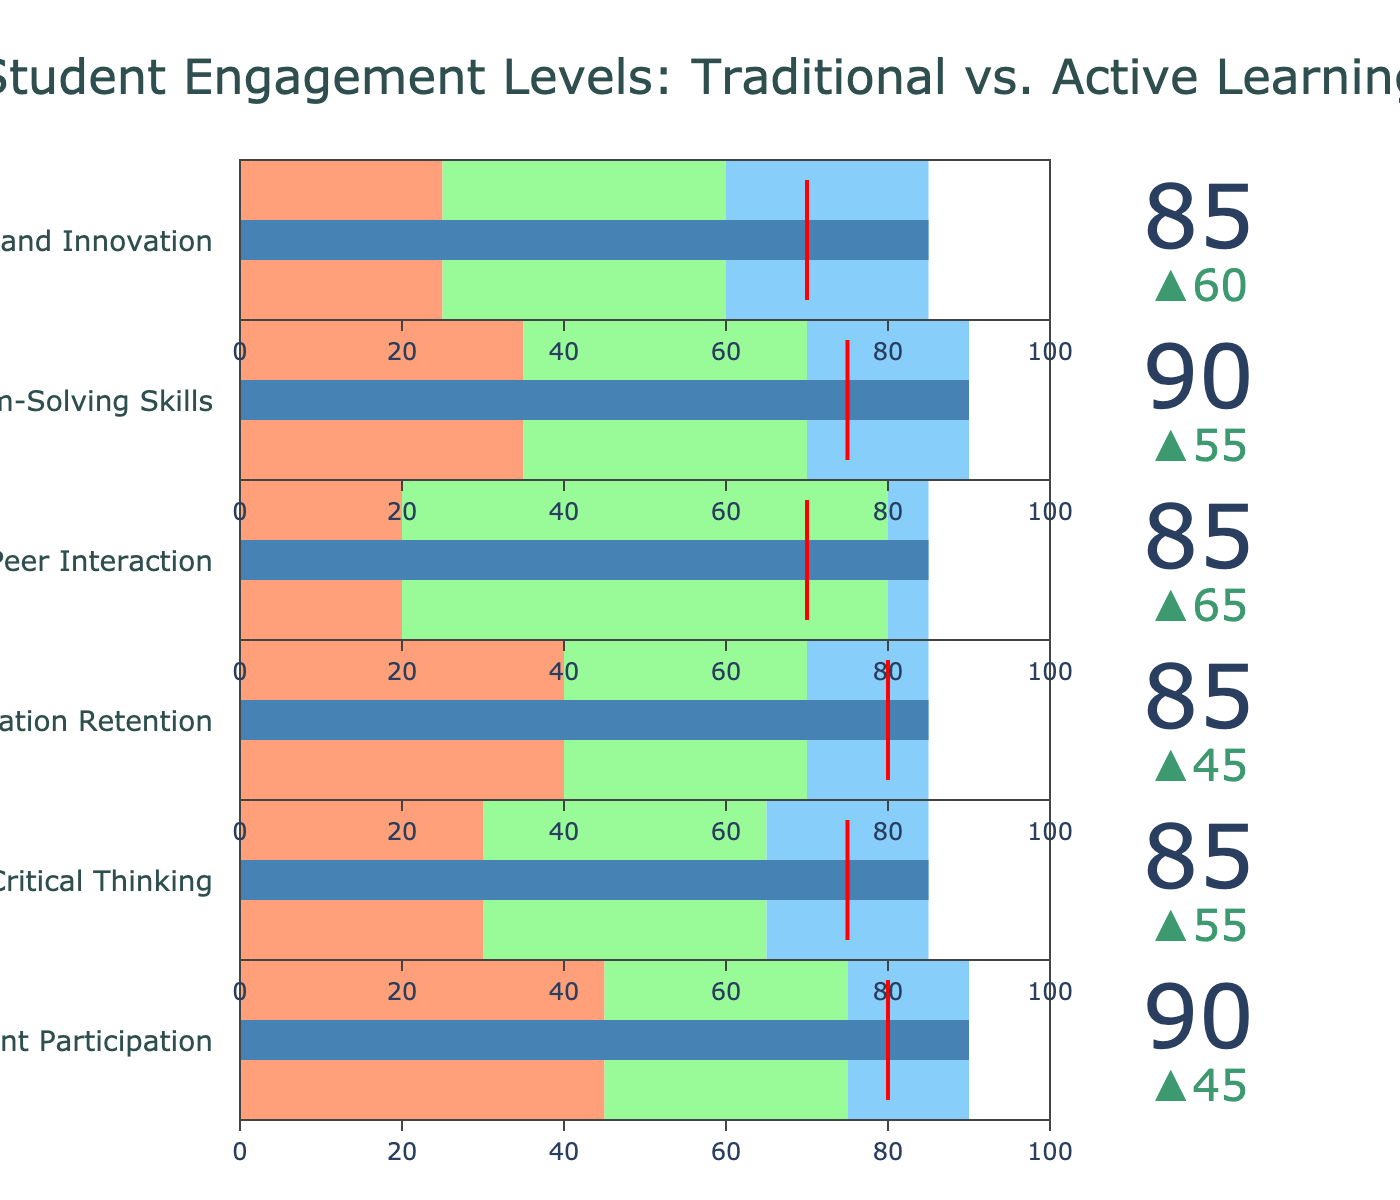How many engagement metrics are compared in the figure? The figure shows a series of bullet charts, each representing a different engagement metric category. By counting the number of distinct bullet charts, we can see that there are six engagement metrics listed.
Answer: Six What is the target value for Student Participation in active learning? The target value for each metric can be seen from the threshold markers labeled "Target." For Student Participation, the threshold marker is set at 80.
Answer: 80 By how much does Peer Interaction increase in active learning compared to traditional lecture? To find the increase, we subtract the Peer Interaction value for traditional lecture (20) from the value for hands-on activities (85). Calculation: 85 - 20 = 65.
Answer: 65 Which engagement metric shows the smallest improvement in hands-on activities compared to traditional lecture? We need to calculate the improvement for each metric by subtracting the traditional lecture value from the hands-on activities value and compare these results. For Peer Interaction: 85 - 20 = 65, for Student Participation: 90 - 45 = 45, for Critical Thinking: 85 - 30 = 55, for Information Retention: 85 - 40 = 45, for Problem-Solving Skills: 90 - 35 = 55, for Creativity and Innovation: 85 - 25 = 60. The smallest improvement is in Student Participation and Information Retention (both 45).
Answer: Student Participation; Information Retention Which metric meets or exceeds its target in active learning? The target values are indicated by a red line in each bullet chart. We compare these target values with the hands-on activities values for each metric: Student Participation (90 vs. 80), Critical Thinking (85 vs. 75), Information Retention (85 vs. 80), Peer Interaction (85 vs. 70), Problem-Solving Skills (90 vs. 75), Creativity and Innovation (85 vs. 70). The metrics exceeding their targets are Student Participation, Critical Thinking, Information Retention, Problem-Solving Skills, and Creativity and Innovation.
Answer: All but Peer Interaction How does the value for Critical Thinking in group work compare to its target value? Comparing the value for Critical Thinking in group work (65) with its target value (75), we can note that it is 10 units below the target.
Answer: 10 units below Which activity category generally results in the highest engagement levels across all metrics? By examining the bullet charts, we observe that hands-on activities result in the highest engagement levels across all six metrics as their values are the furthest to the right.
Answer: Hands-on Activities What is the range of values for Information Retention? The range can be determined by the minimum and maximum observed values. The minimum comes from traditional lecture (40) and the maximum from hands-on activities (85), giving a range of 85 - 40 = 45.
Answer: 45 How much higher is Student Participation engagement in group work compared to traditional lecture? By comparing the Student Participation values, we subtract the value of traditional lecture (45) from the group work value (75). Calculation: 75 - 45 = 30.
Answer: 30 Which metric has the highest target value? The target values are marked by red lines for each metric. All metrics have the same maximum target value of 100, so we look at the individual target values and find that all target values are individualized and Student Participation (80) is the same highest alongside some others.
Answer: All of them 